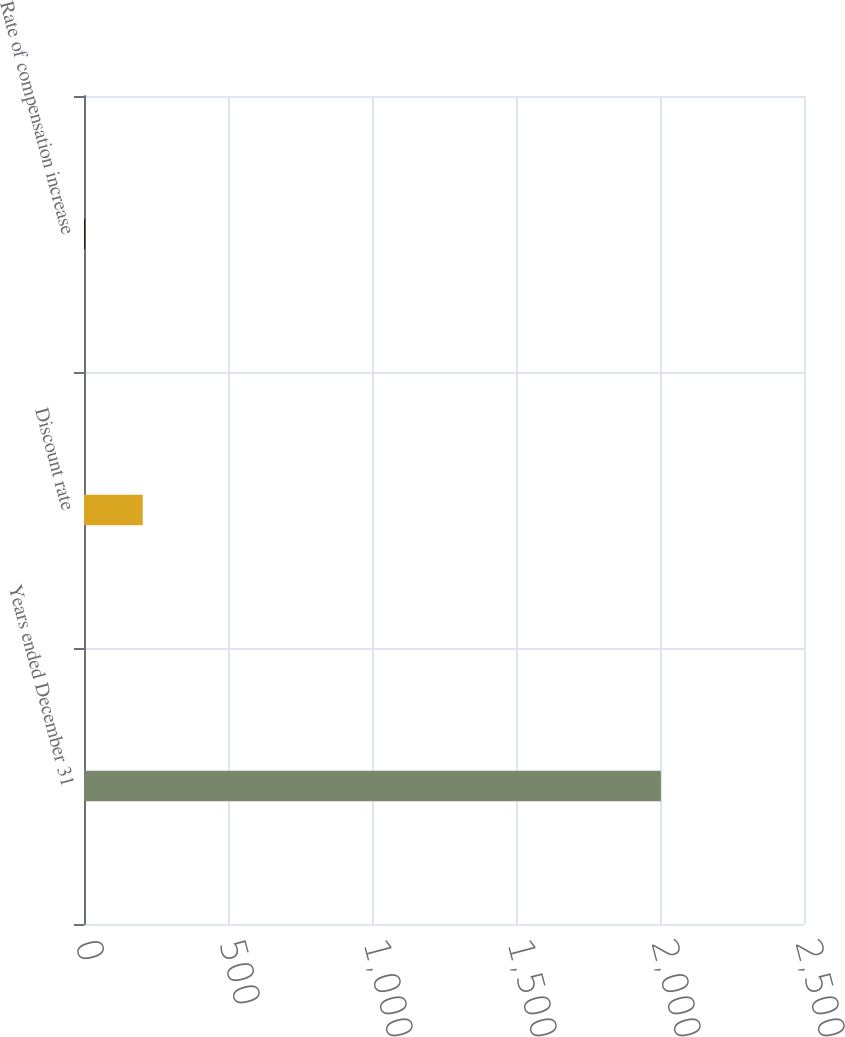<chart> <loc_0><loc_0><loc_500><loc_500><bar_chart><fcel>Years ended December 31<fcel>Discount rate<fcel>Rate of compensation increase<nl><fcel>2003<fcel>203.9<fcel>4<nl></chart> 